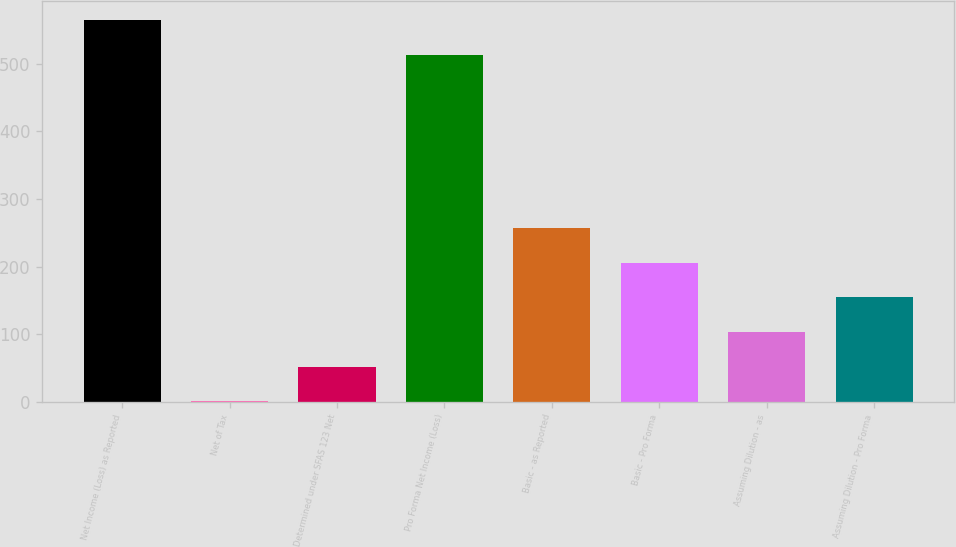Convert chart. <chart><loc_0><loc_0><loc_500><loc_500><bar_chart><fcel>Net Income (Loss) as Reported<fcel>Net of Tax<fcel>Determined under SFAS 123 Net<fcel>Pro Forma Net Income (Loss)<fcel>Basic - as Reported<fcel>Basic - Pro Forma<fcel>Assuming Dilution - as<fcel>Assuming Dilution - Pro Forma<nl><fcel>564.39<fcel>0.7<fcel>51.99<fcel>513.1<fcel>257.15<fcel>205.86<fcel>103.28<fcel>154.57<nl></chart> 